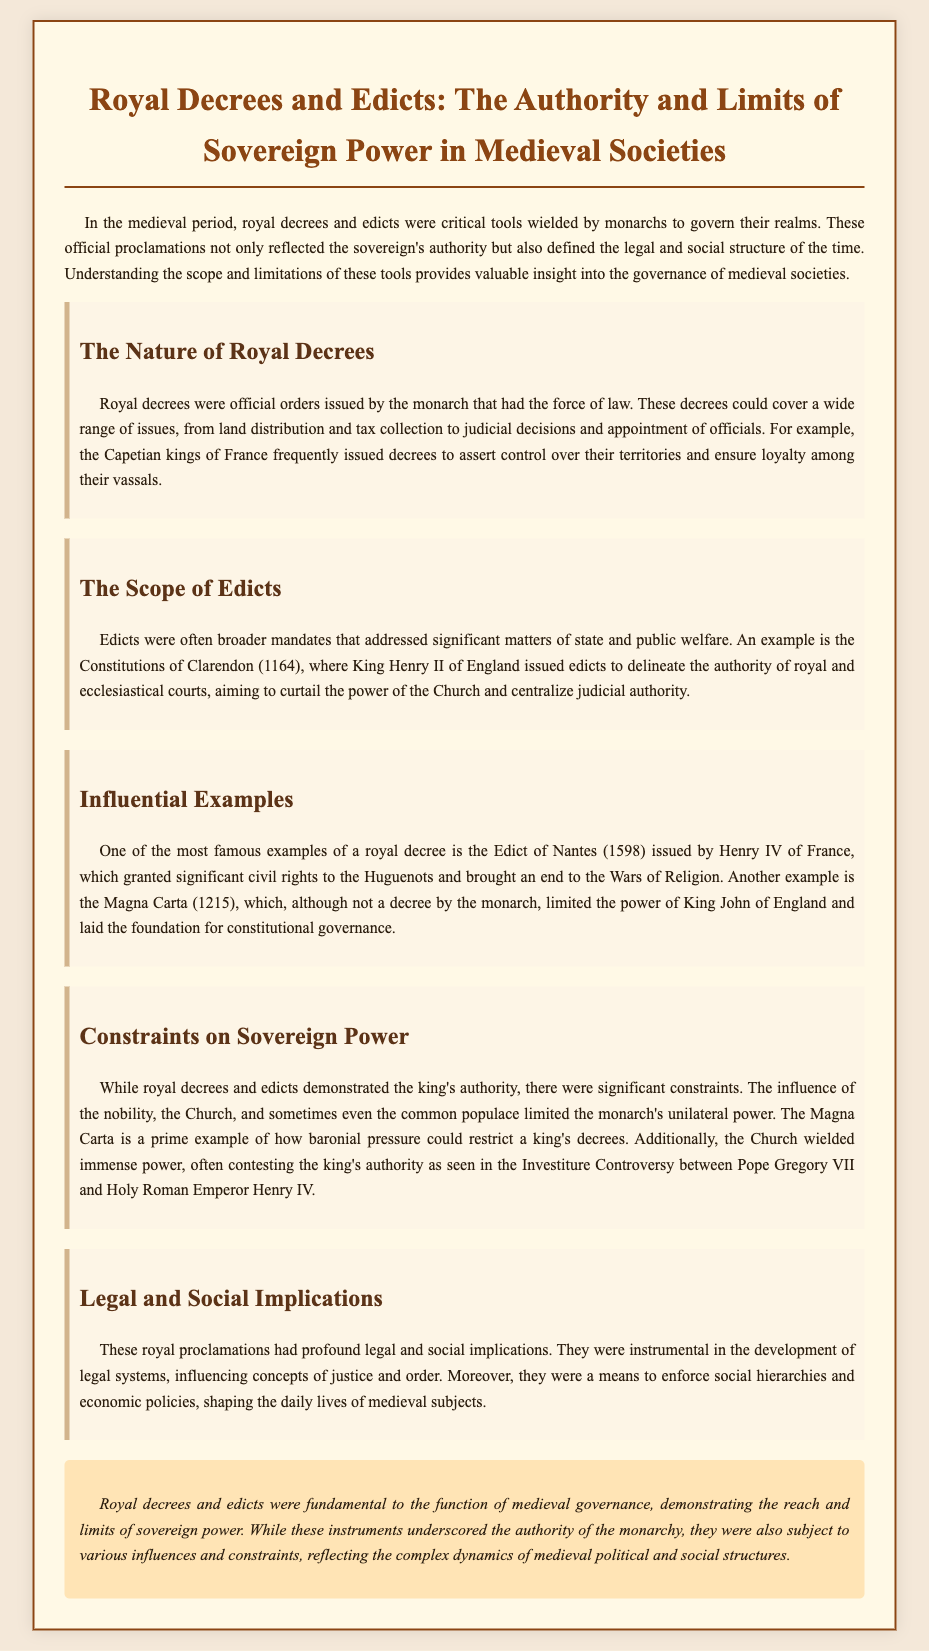What were royal decrees? Royal decrees were official orders issued by the monarch that had the force of law.
Answer: Official orders What significant document limited King John's power? The Magna Carta is a document that limited the power of King John of England.
Answer: Magna Carta Who issued the Constitutions of Clarendon? King Henry II of England issued the Constitutions of Clarendon in 1164.
Answer: King Henry II What was the Edict of Nantes? The Edict of Nantes granted significant civil rights to the Huguenots and ended the Wars of Religion.
Answer: Civil rights for Huguenots What influenced constraints on sovereign power? The influence of the nobility, the Church, and the common populace limited the monarch's power.
Answer: Nobility, Church, populace What did royal decrees influence in medieval societies? Royal decrees were instrumental in the development of legal systems and influenced concepts of justice and order.
Answer: Legal systems What was the purpose of royal decrees according to the document? Royal decrees asserted control over territories and ensured loyalty among vassals.
Answer: Control and loyalty What is a key theme discussed in the legal brief? The reach and limits of sovereign power in medieval governance are key themes discussed.
Answer: Sovereign power limits 